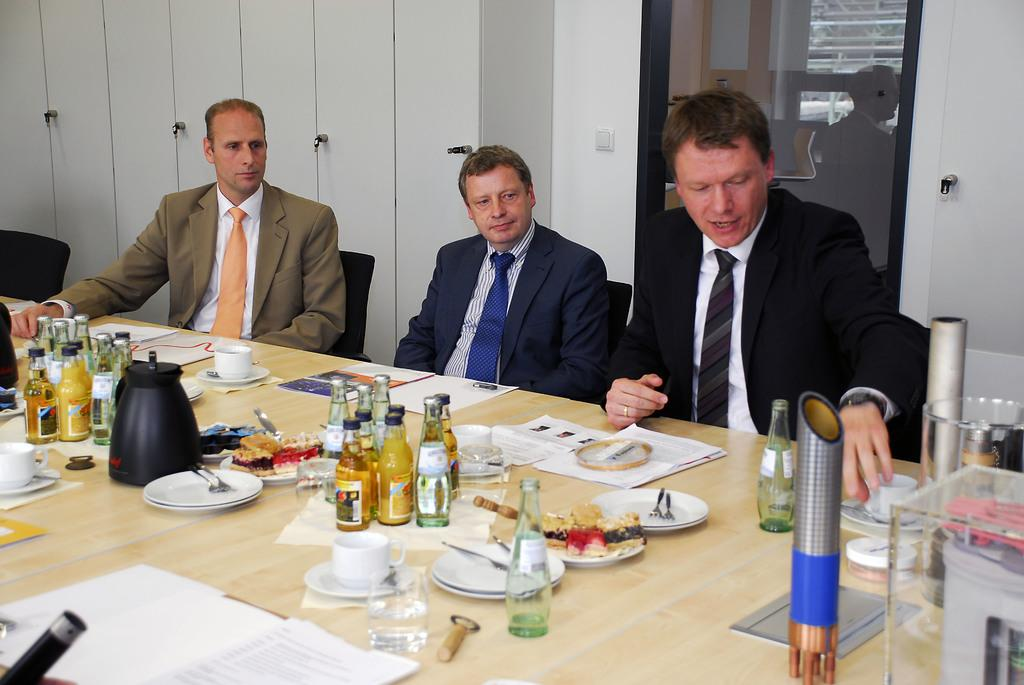How many people are in the image? There are three persons in the image. What are the persons doing in the image? The persons are sitting on chairs. What is in front of the persons? There is a table in front of them. What can be found on the table? The table has eatables, drinks, and papers on it. What type of caption is written on the papers on the table? There is no information about a caption on the papers in the image. What is the chance of finding a sock on the table? There is no sock present on the table in the image. 